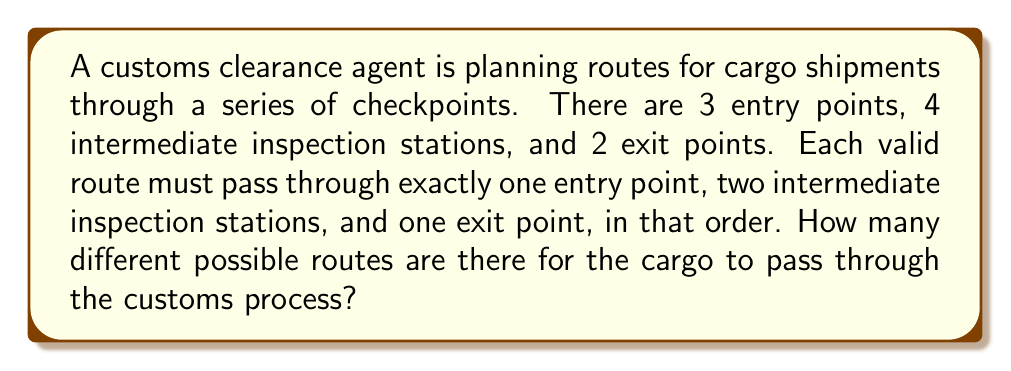Show me your answer to this math problem. Let's break this down step-by-step:

1) First, we need to choose an entry point:
   There are 3 choices for this, so we have 3 options.

2) Next, we need to choose 2 intermediate inspection stations out of 4:
   This is a combination problem, as the order doesn't matter (the cargo will pass through both chosen stations regardless of order).
   We can represent this as $\binom{4}{2}$.

3) Finally, we need to choose an exit point:
   There are 2 choices for this.

4) According to the multiplication principle, if we have a series of independent choices, we multiply the number of options for each choice to get the total number of possibilities.

5) Therefore, the total number of possible routes is:

   $$ 3 \cdot \binom{4}{2} \cdot 2 $$

6) Let's calculate $\binom{4}{2}$:
   $$ \binom{4}{2} = \frac{4!}{2!(4-2)!} = \frac{4 \cdot 3}{2 \cdot 1} = 6 $$

7) Now we can compute the final result:
   $$ 3 \cdot 6 \cdot 2 = 36 $$

Thus, there are 36 different possible routes for the cargo to pass through the customs process.
Answer: 36 possible routes 